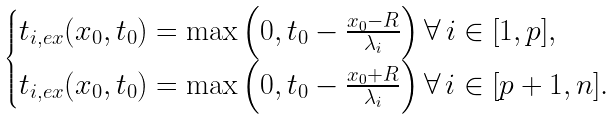<formula> <loc_0><loc_0><loc_500><loc_500>\begin{cases} t _ { i , e x } ( x _ { 0 } , t _ { 0 } ) = \max \left ( 0 , t _ { 0 } - \frac { x _ { 0 } - R } { \lambda _ { i } } \right ) \forall \, i \in [ 1 , p ] , \\ t _ { i , e x } ( x _ { 0 } , t _ { 0 } ) = \max \left ( 0 , t _ { 0 } - \frac { x _ { 0 } + R } { \lambda _ { i } } \right ) \forall \, i \in [ p + 1 , n ] . \end{cases}</formula> 